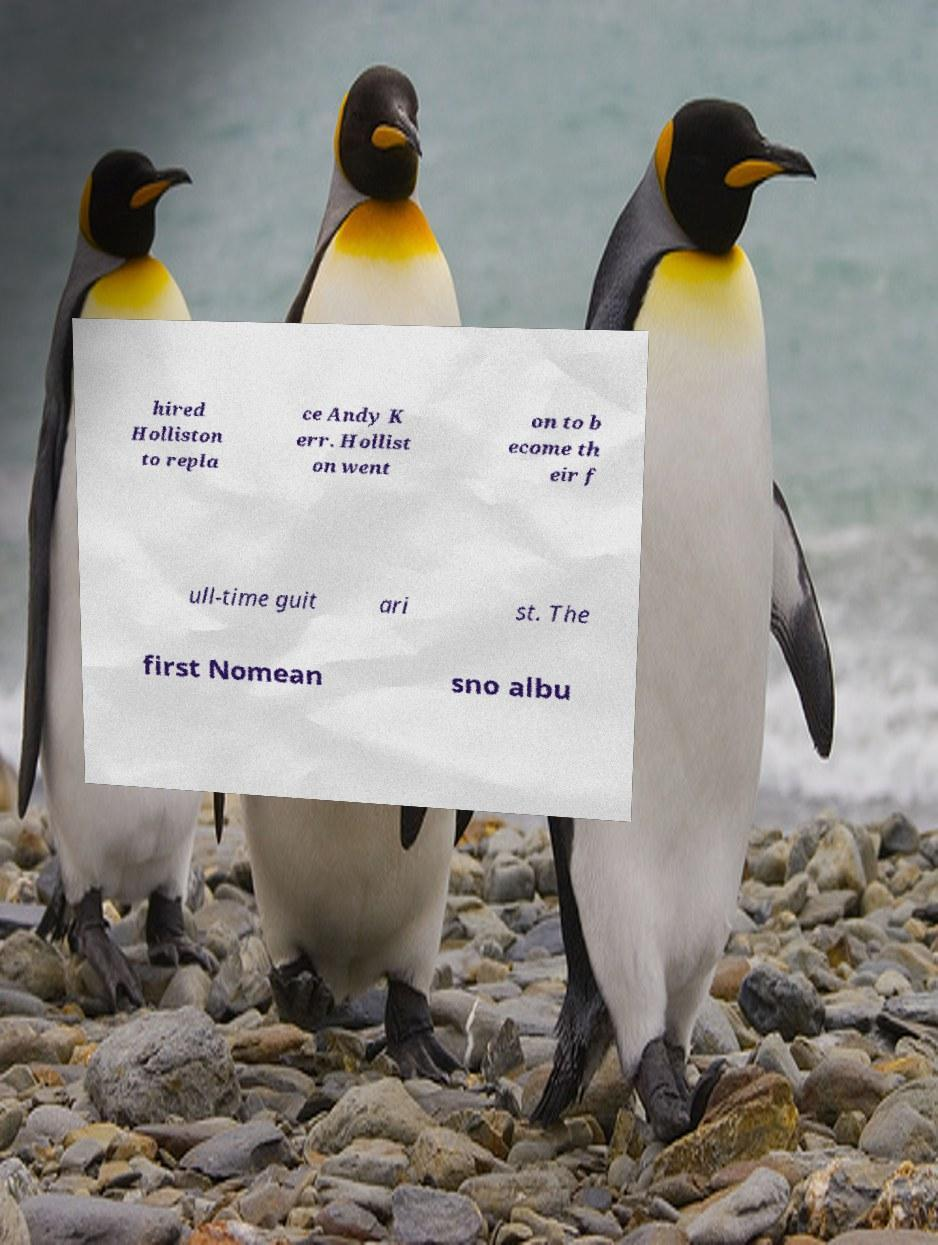I need the written content from this picture converted into text. Can you do that? hired Holliston to repla ce Andy K err. Hollist on went on to b ecome th eir f ull-time guit ari st. The first Nomean sno albu 